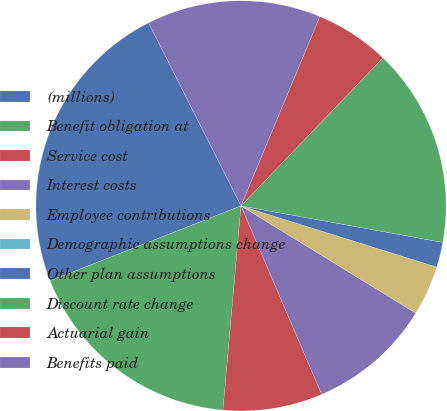<chart> <loc_0><loc_0><loc_500><loc_500><pie_chart><fcel>(millions)<fcel>Benefit obligation at<fcel>Service cost<fcel>Interest costs<fcel>Employee contributions<fcel>Demographic assumptions change<fcel>Other plan assumptions<fcel>Discount rate change<fcel>Actuarial gain<fcel>Benefits paid<nl><fcel>23.52%<fcel>17.64%<fcel>7.84%<fcel>9.8%<fcel>3.93%<fcel>0.01%<fcel>1.97%<fcel>15.68%<fcel>5.89%<fcel>13.72%<nl></chart> 